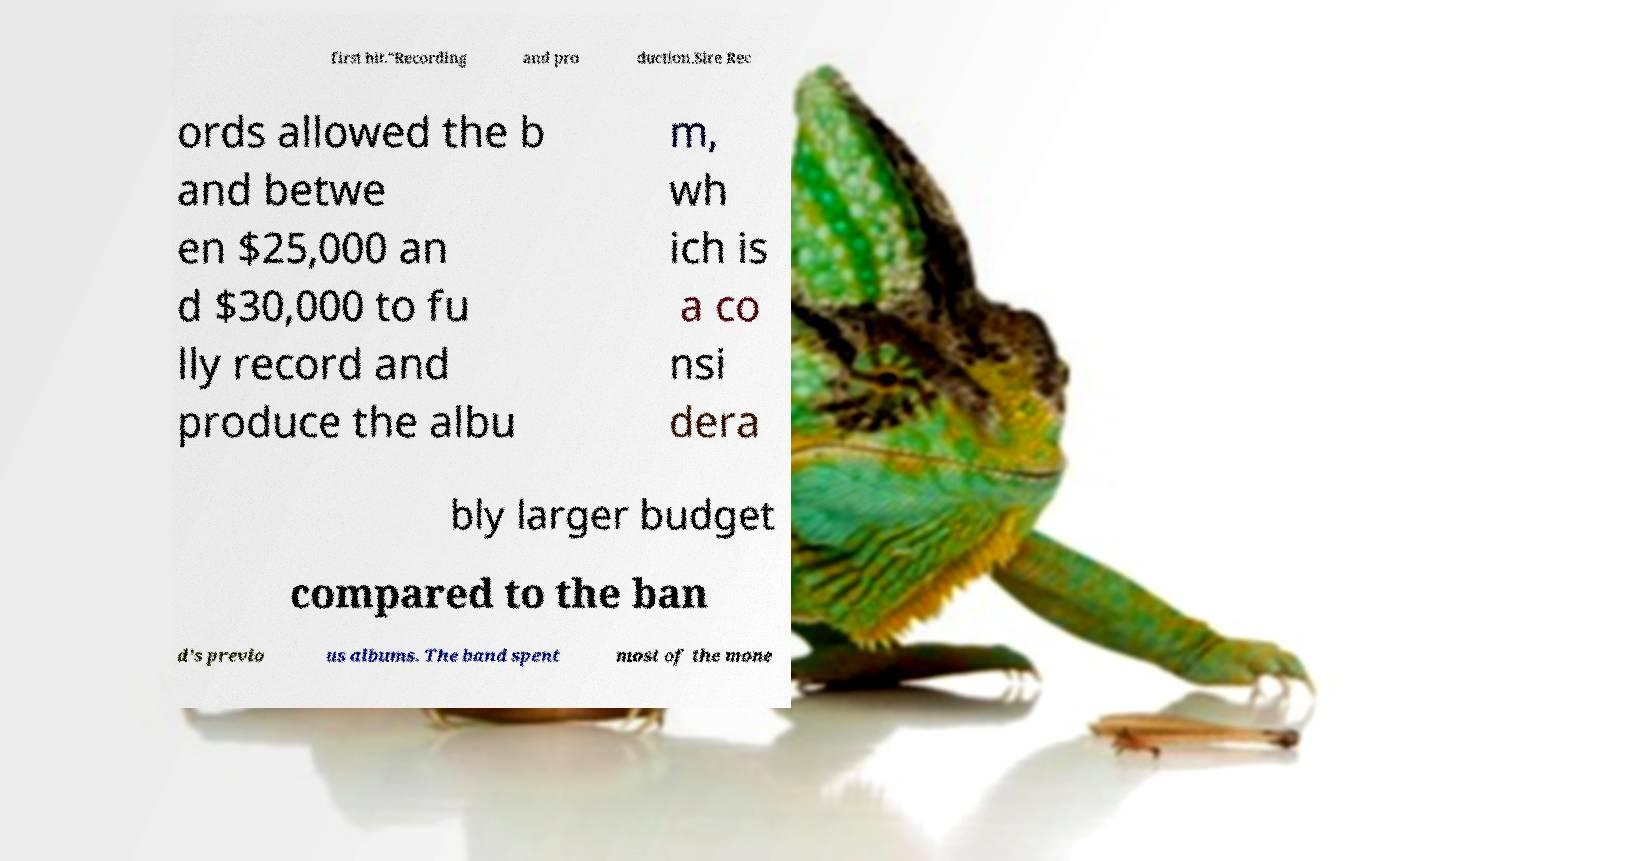Please read and relay the text visible in this image. What does it say? first hit."Recording and pro duction.Sire Rec ords allowed the b and betwe en $25,000 an d $30,000 to fu lly record and produce the albu m, wh ich is a co nsi dera bly larger budget compared to the ban d's previo us albums. The band spent most of the mone 